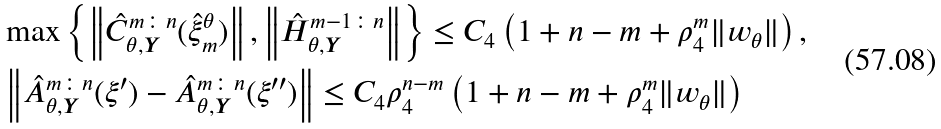<formula> <loc_0><loc_0><loc_500><loc_500>& \max \left \{ \left \| \hat { C } _ { \theta , \boldsymbol Y } ^ { m \colon n } ( \hat { \xi } _ { m } ^ { \theta } ) \right \| , \left \| \hat { H } _ { \theta , \boldsymbol Y } ^ { m - 1 \colon n } \right \| \right \} \leq C _ { 4 } \left ( 1 + n - m + \rho _ { 4 } ^ { m } \| w _ { \theta } \| \right ) , \\ & \left \| \hat { A } _ { \theta , \boldsymbol Y } ^ { m \colon n } ( \xi ^ { \prime } ) - \hat { A } _ { \theta , \boldsymbol Y } ^ { m \colon n } ( \xi ^ { \prime \prime } ) \right \| \leq C _ { 4 } \rho _ { 4 } ^ { n - m } \left ( 1 + n - m + \rho _ { 4 } ^ { m } \| w _ { \theta } \| \right )</formula> 